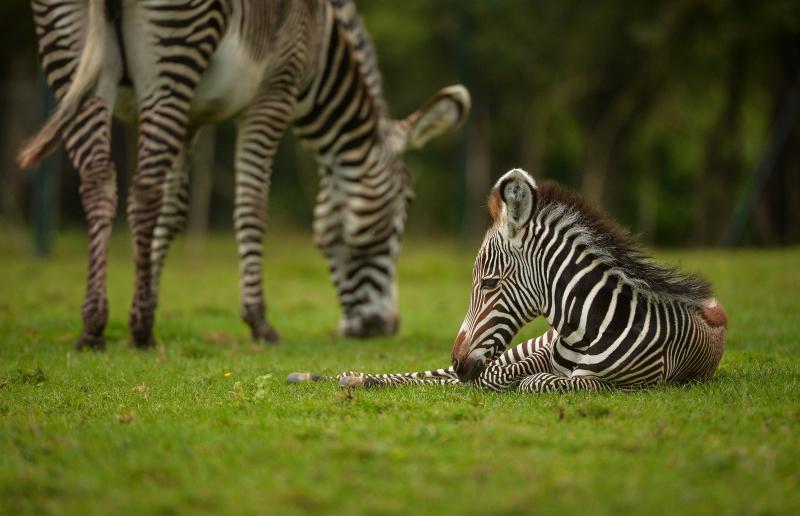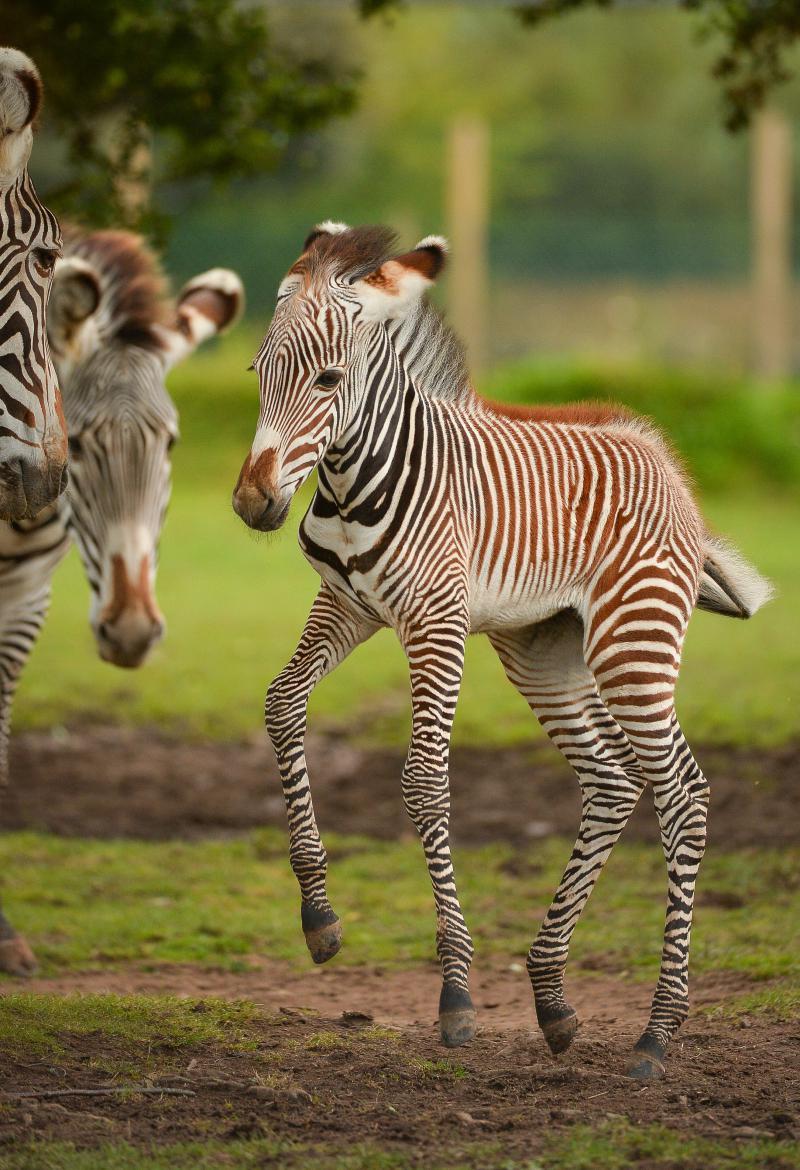The first image is the image on the left, the second image is the image on the right. For the images displayed, is the sentence "At least one baby zebra is staying close to its mom." factually correct? Answer yes or no. Yes. The first image is the image on the left, the second image is the image on the right. Evaluate the accuracy of this statement regarding the images: "Each image contains two zebras of similar size, and in at least one image, the head of one zebra is over the back of the other zebra.". Is it true? Answer yes or no. No. 